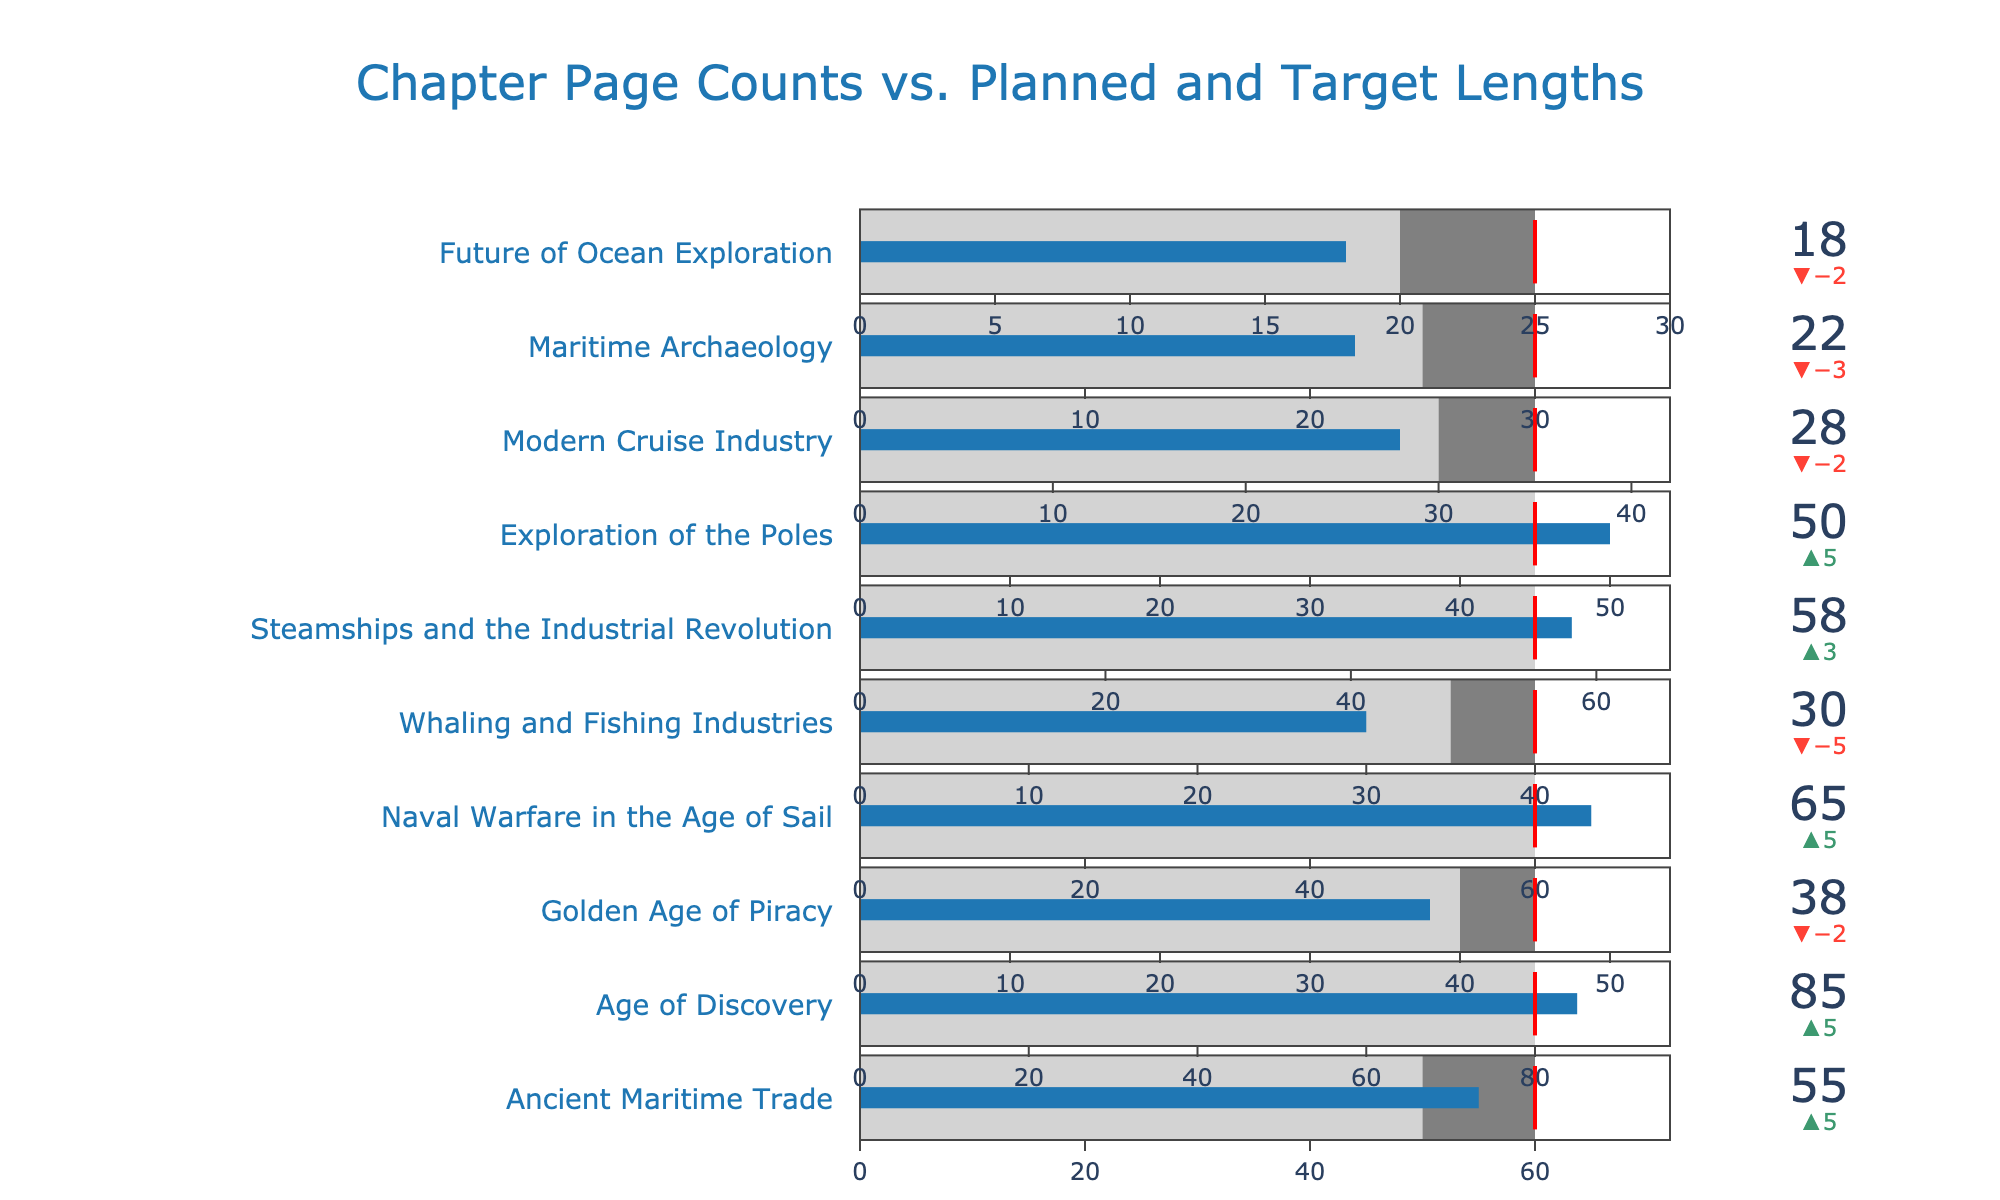What's the title of the visual representation? The title is placed prominently at the top of the visual representation, written in a large font and a distinct color, making it easy to identify.
Answer: Chapter Page Counts vs. Planned and Target Lengths How many chapters have more actual pages than planned pages? To find this, count the chapters where the actual pages indicator bar extends beyond the planned pages zone (light gray).
Answer: 5 Which chapter has the largest difference between actual pages and planned pages? Look for the chapter with the greatest delta from the planned pages (green/red delta value). "Naval Warfare in the Age of Sail" shows the largest delta with +5 pages.
Answer: Naval Warfare in the Age of Sail For which chapters did the actual pages meet the target pages? Target pages are shown as a red threshold. Identify chapters where the actual pages bar stops at the red threshold line.
Answer: Age of Discovery, Steamships and the Industrial Revolution, Exploration of the Poles What's the total number of actual pages for the chapters that have fewer actual pages than planned? Sum the actual pages for chapters where the actual pages indicator bar extends below the planned pages border. Chapters: 'Golden Age of Piracy', 'Whaling and Fishing Industries', 'Modern Cruise Industry', 'Maritime Archaeology', and 'Future of Ocean Exploration' have actual pages of 38, 30, 28, 22, and 18 respectively. The total is 38 + 30 + 28 + 22 + 18 = 136
Answer: 136 What’s the shortest chapter in terms of actual pages? Identify the chapter with the smallest actual pages value, represented by the shortest bar. "Future of Ocean Exploration" is the shortest with 18 pages.
Answer: Future of Ocean Exploration How many chapters exceed their target page counts? Compare the actual pages bar with the red threshold line for each chapter. Count the chapters where the bar goes beyond this threshold.
Answer: 1 Which chapters have exactly the same number of planned and actual pages? Look for chapters where the actual pages bar height exactly matches the height of the planned pages zone. The "Age of Discovery" chapter has the same planned and actual pages, both at 80.
Answer: Age of Discovery Which chapters planned for 45 pages? Identify chapters with a planned pages zone that ends at 45. The chapters are "Exploration of the Poles" and "Golden Age of Piracy".
Answer: Exploration of the Poles, Golden Age of Piracy 